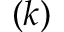<formula> <loc_0><loc_0><loc_500><loc_500>( k )</formula> 